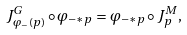Convert formula to latex. <formula><loc_0><loc_0><loc_500><loc_500>J ^ { G } _ { \varphi _ { - } ( p ) } \circ \varphi _ { - * p } = \varphi _ { - * p } \circ J ^ { M } _ { p } ,</formula> 